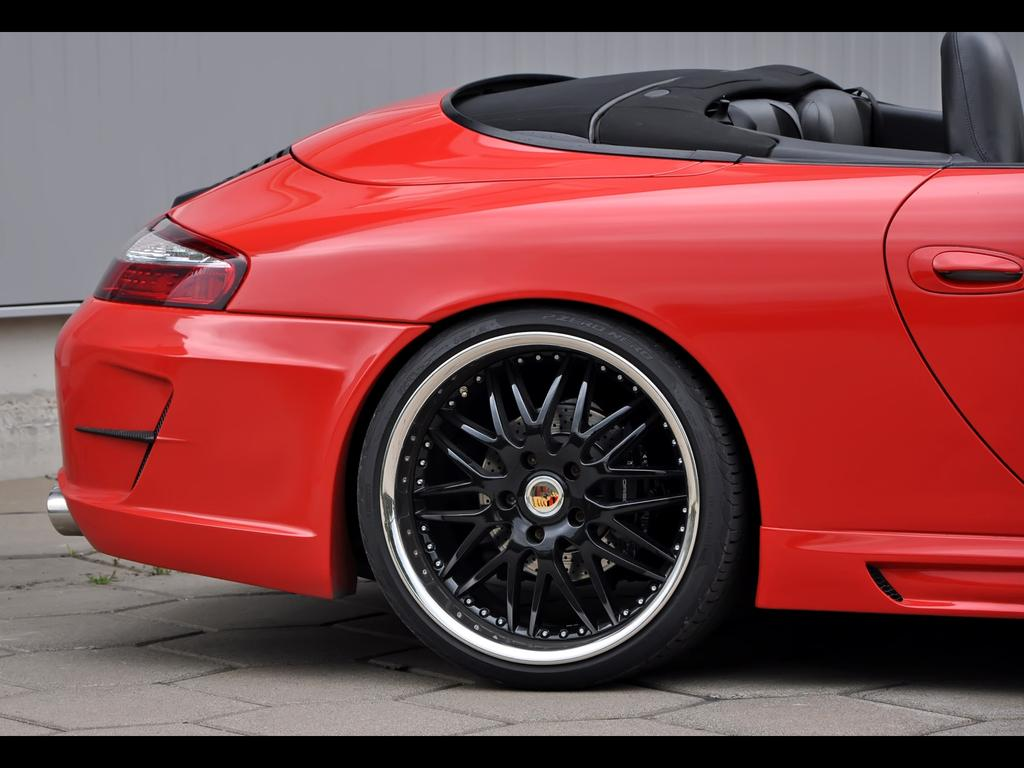What color is the car in the image? The car in the image is red. Where is the car located in the image? The car is on the road in the image. What can be observed about the image's borders? The image has black borders. How many fish can be seen swimming in the car's engine in the image? There are no fish present in the image, and the car's engine is not visible. 